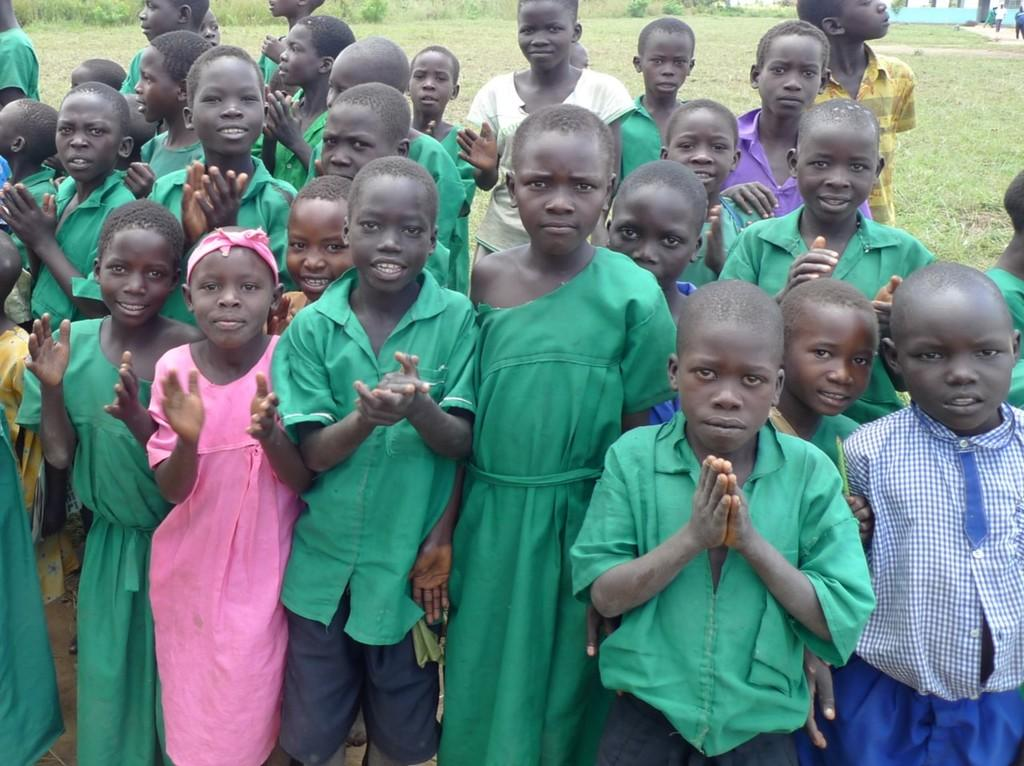How many children are present in the image? There are many children in the image. What type of natural environment is visible in the background of the image? There is grass in the background of the image. What other elements can be seen in the background of the image? There are plants and a building visible in the background of the image. What type of territory is being claimed by the children in the image? There is no indication in the image that the children are claiming any territory. What type of current is flowing through the image? There is no water or current visible in the image. 